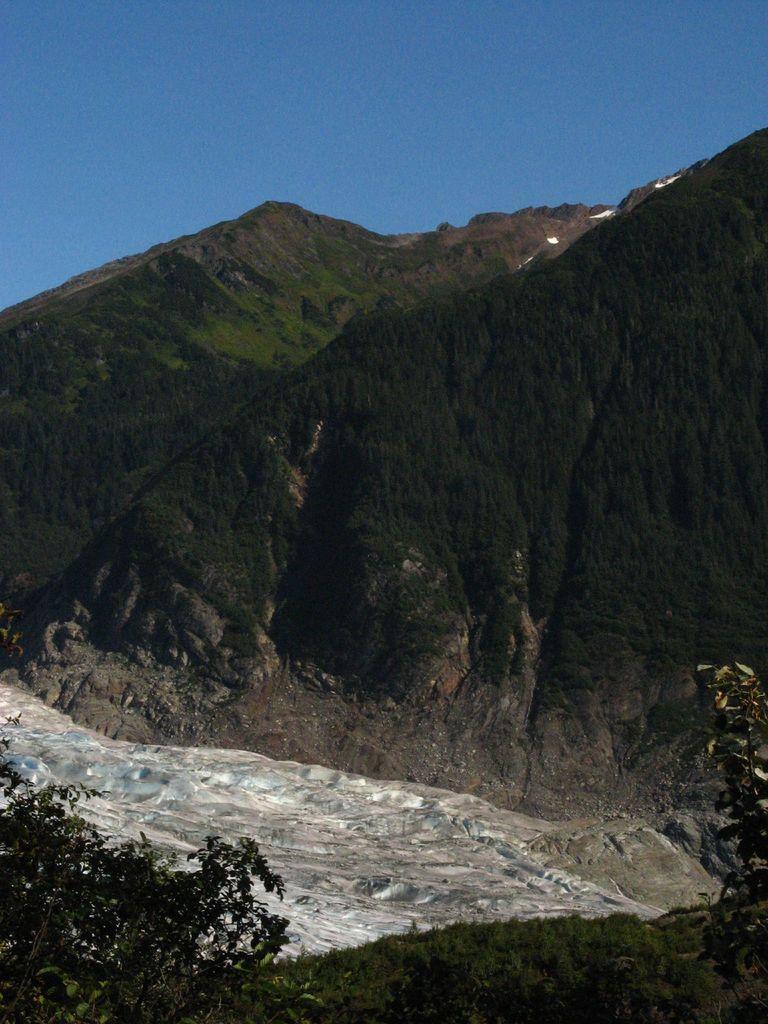How would you summarize this image in a sentence or two? This picture might be taken from outside of the city. In this image, on the left corner, we can see some plants. On the right side, we can see some plants. In the background, we can see some trees, plants, rocks. At the top, we can see a sky, at the bottom, we can see grass and some stones. 